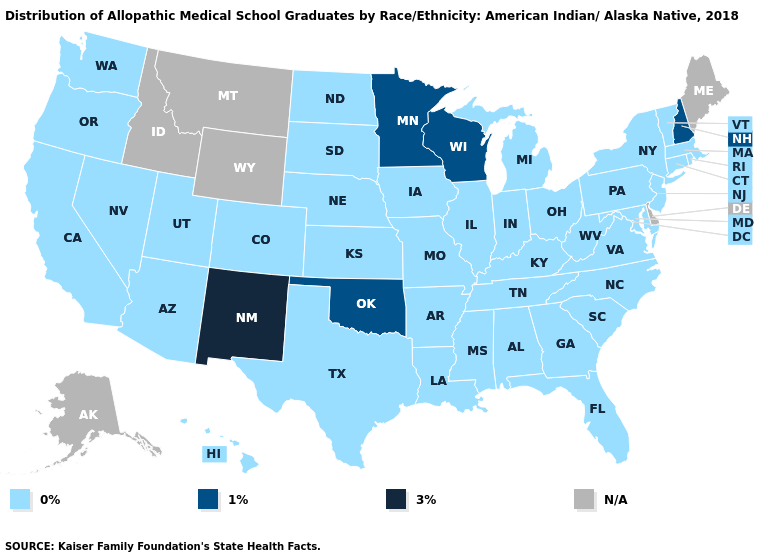Among the states that border Delaware , which have the lowest value?
Quick response, please. Maryland, New Jersey, Pennsylvania. What is the lowest value in the Northeast?
Keep it brief. 0%. Which states hav the highest value in the MidWest?
Short answer required. Minnesota, Wisconsin. Which states have the lowest value in the MidWest?
Answer briefly. Illinois, Indiana, Iowa, Kansas, Michigan, Missouri, Nebraska, North Dakota, Ohio, South Dakota. Name the states that have a value in the range 0%?
Be succinct. Alabama, Arizona, Arkansas, California, Colorado, Connecticut, Florida, Georgia, Hawaii, Illinois, Indiana, Iowa, Kansas, Kentucky, Louisiana, Maryland, Massachusetts, Michigan, Mississippi, Missouri, Nebraska, Nevada, New Jersey, New York, North Carolina, North Dakota, Ohio, Oregon, Pennsylvania, Rhode Island, South Carolina, South Dakota, Tennessee, Texas, Utah, Vermont, Virginia, Washington, West Virginia. Which states have the lowest value in the MidWest?
Be succinct. Illinois, Indiana, Iowa, Kansas, Michigan, Missouri, Nebraska, North Dakota, Ohio, South Dakota. What is the lowest value in the USA?
Give a very brief answer. 0%. Does Washington have the lowest value in the West?
Give a very brief answer. Yes. Is the legend a continuous bar?
Quick response, please. No. Name the states that have a value in the range 0%?
Answer briefly. Alabama, Arizona, Arkansas, California, Colorado, Connecticut, Florida, Georgia, Hawaii, Illinois, Indiana, Iowa, Kansas, Kentucky, Louisiana, Maryland, Massachusetts, Michigan, Mississippi, Missouri, Nebraska, Nevada, New Jersey, New York, North Carolina, North Dakota, Ohio, Oregon, Pennsylvania, Rhode Island, South Carolina, South Dakota, Tennessee, Texas, Utah, Vermont, Virginia, Washington, West Virginia. What is the value of Washington?
Quick response, please. 0%. Does Georgia have the highest value in the South?
Give a very brief answer. No. Does North Carolina have the highest value in the USA?
Give a very brief answer. No. 